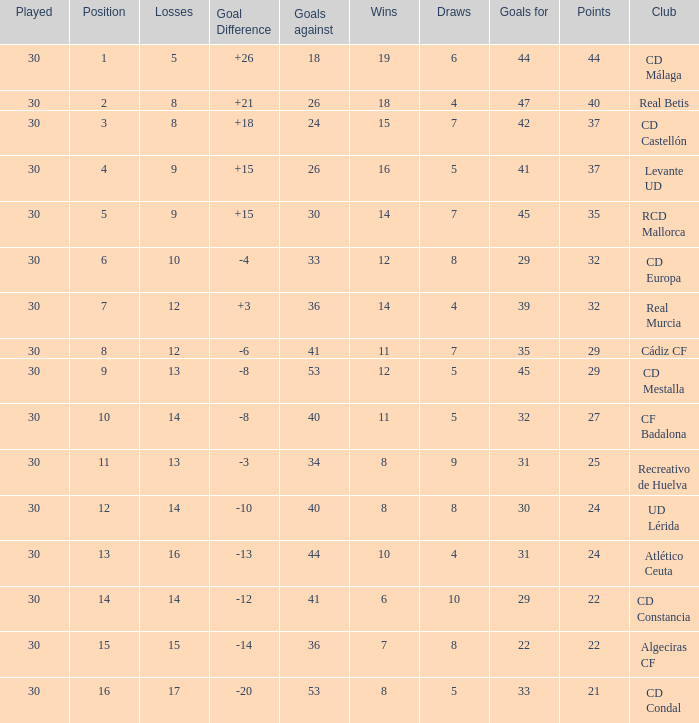What is the losses when the goal difference is larger than 26? None. 